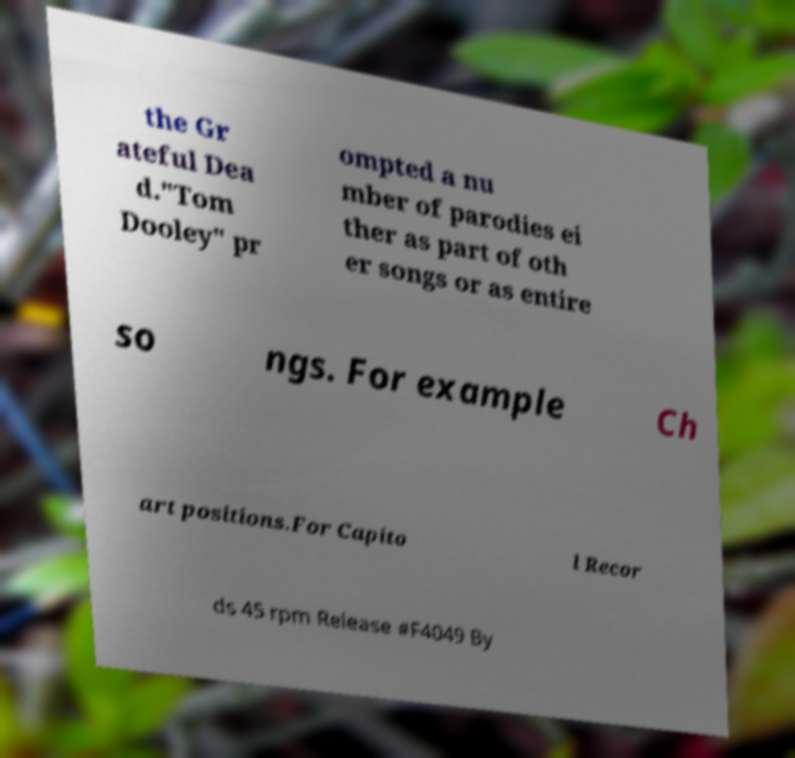Could you extract and type out the text from this image? the Gr ateful Dea d."Tom Dooley" pr ompted a nu mber of parodies ei ther as part of oth er songs or as entire so ngs. For example Ch art positions.For Capito l Recor ds 45 rpm Release #F4049 By 